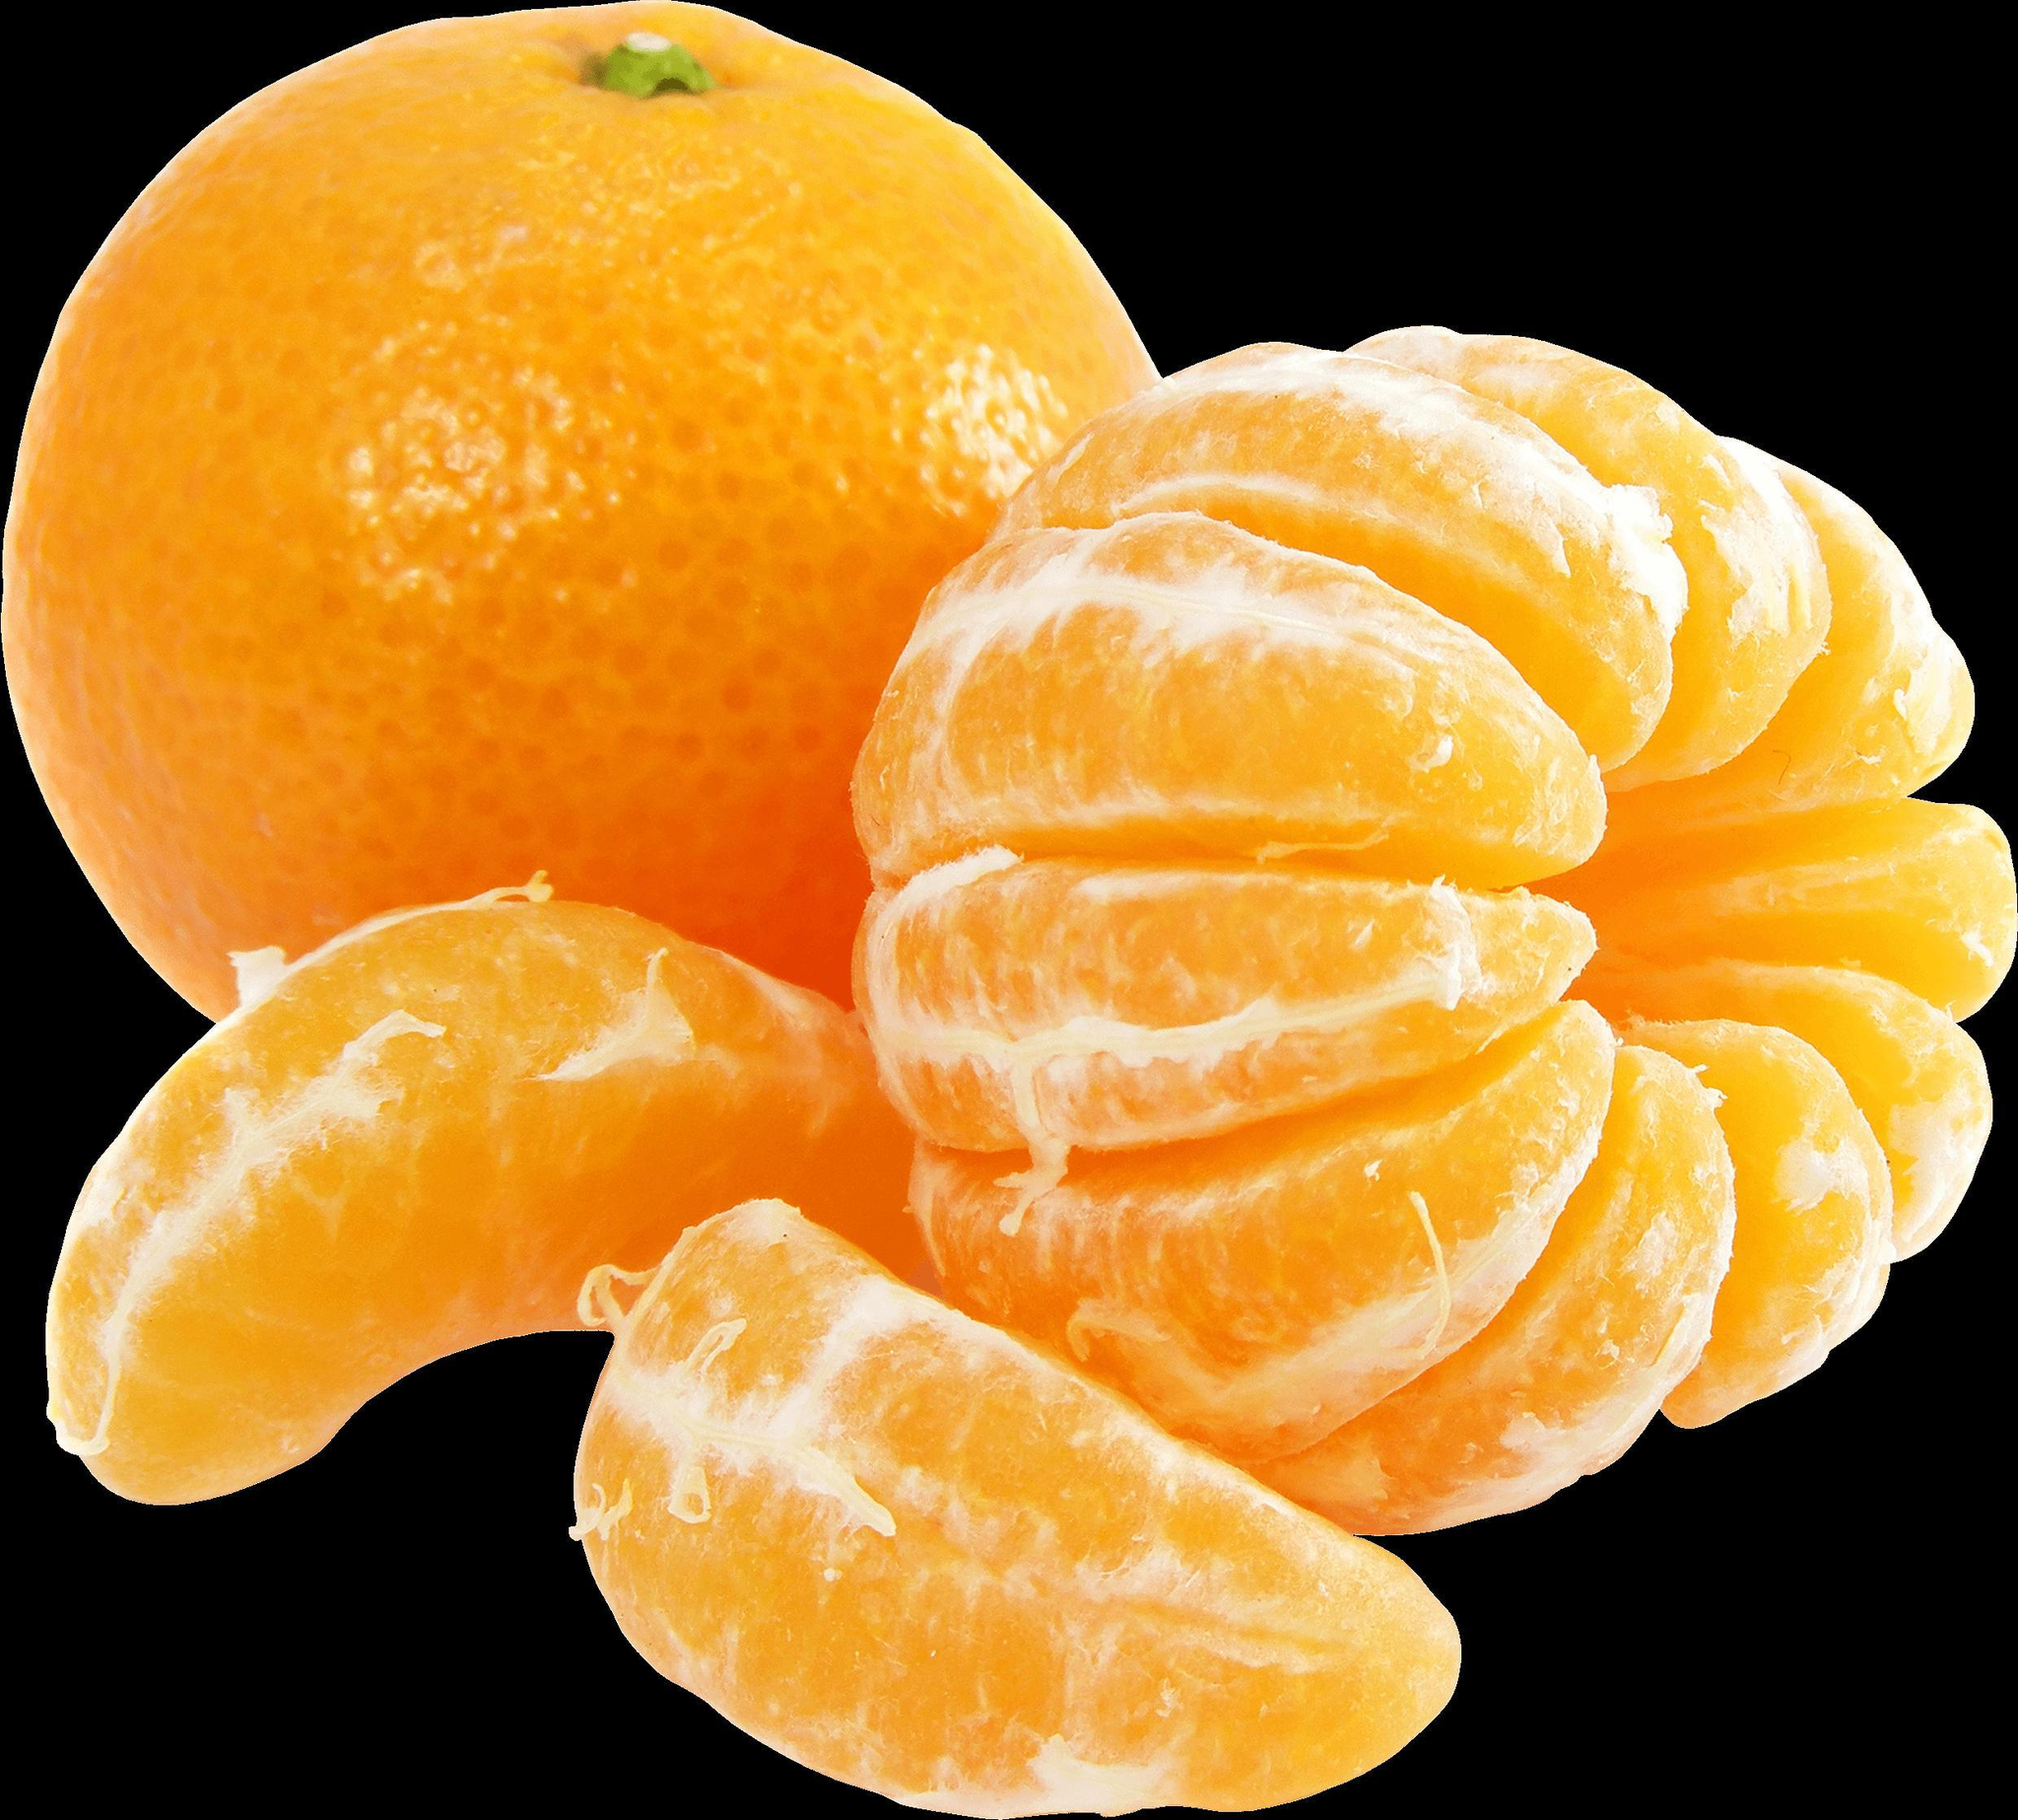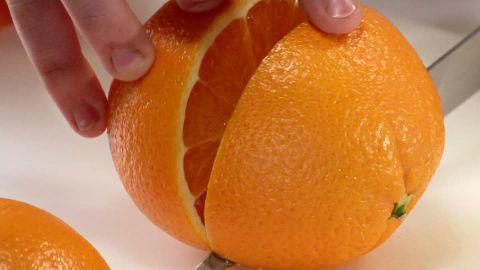The first image is the image on the left, the second image is the image on the right. Evaluate the accuracy of this statement regarding the images: "The left image contains at least one orange wedge and nothing else, and the right image contains at least one orange slice and nothing else.". Is it true? Answer yes or no. No. The first image is the image on the left, the second image is the image on the right. Analyze the images presented: Is the assertion "There is one whole uncut orange in the left image." valid? Answer yes or no. Yes. 